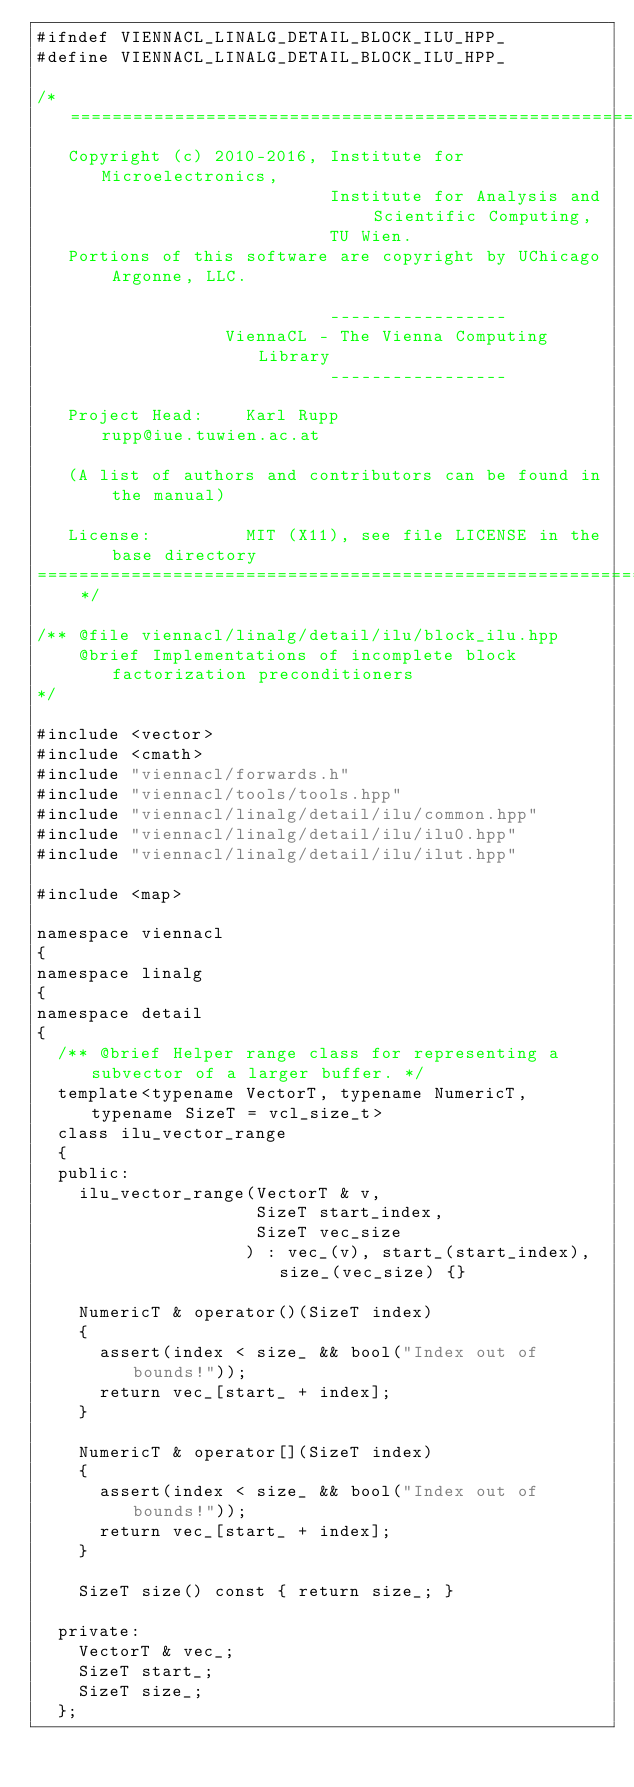<code> <loc_0><loc_0><loc_500><loc_500><_C++_>#ifndef VIENNACL_LINALG_DETAIL_BLOCK_ILU_HPP_
#define VIENNACL_LINALG_DETAIL_BLOCK_ILU_HPP_

/* =========================================================================
   Copyright (c) 2010-2016, Institute for Microelectronics,
                            Institute for Analysis and Scientific Computing,
                            TU Wien.
   Portions of this software are copyright by UChicago Argonne, LLC.

                            -----------------
                  ViennaCL - The Vienna Computing Library
                            -----------------

   Project Head:    Karl Rupp                   rupp@iue.tuwien.ac.at

   (A list of authors and contributors can be found in the manual)

   License:         MIT (X11), see file LICENSE in the base directory
============================================================================= */

/** @file viennacl/linalg/detail/ilu/block_ilu.hpp
    @brief Implementations of incomplete block factorization preconditioners
*/

#include <vector>
#include <cmath>
#include "viennacl/forwards.h"
#include "viennacl/tools/tools.hpp"
#include "viennacl/linalg/detail/ilu/common.hpp"
#include "viennacl/linalg/detail/ilu/ilu0.hpp"
#include "viennacl/linalg/detail/ilu/ilut.hpp"

#include <map>

namespace viennacl
{
namespace linalg
{
namespace detail
{
  /** @brief Helper range class for representing a subvector of a larger buffer. */
  template<typename VectorT, typename NumericT, typename SizeT = vcl_size_t>
  class ilu_vector_range
  {
  public:
    ilu_vector_range(VectorT & v,
                     SizeT start_index,
                     SizeT vec_size
                    ) : vec_(v), start_(start_index), size_(vec_size) {}

    NumericT & operator()(SizeT index)
    {
      assert(index < size_ && bool("Index out of bounds!"));
      return vec_[start_ + index];
    }

    NumericT & operator[](SizeT index)
    {
      assert(index < size_ && bool("Index out of bounds!"));
      return vec_[start_ + index];
    }

    SizeT size() const { return size_; }

  private:
    VectorT & vec_;
    SizeT start_;
    SizeT size_;
  };
</code> 